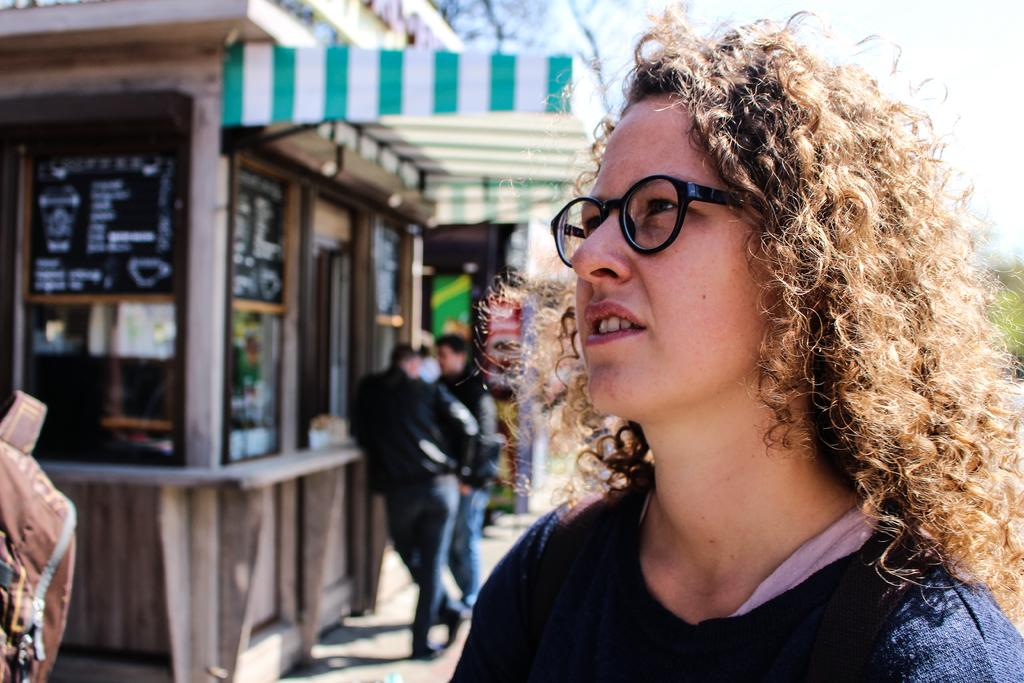Who is present in the image? There is a woman in the image. What is the woman wearing? The woman is wearing glasses. Can you describe the background of the image? The background of the image is blurry. What is the woman holding in the image? There is a bag in the image. How many people are present in the image? There are people in the image. What else can be seen in the image besides the woman and the bag? There are banners and other objects in the image. What type of soda is the woman drinking in the image? There is no soda present in the image. Where is the library located in the image? There is no library present in the image. 